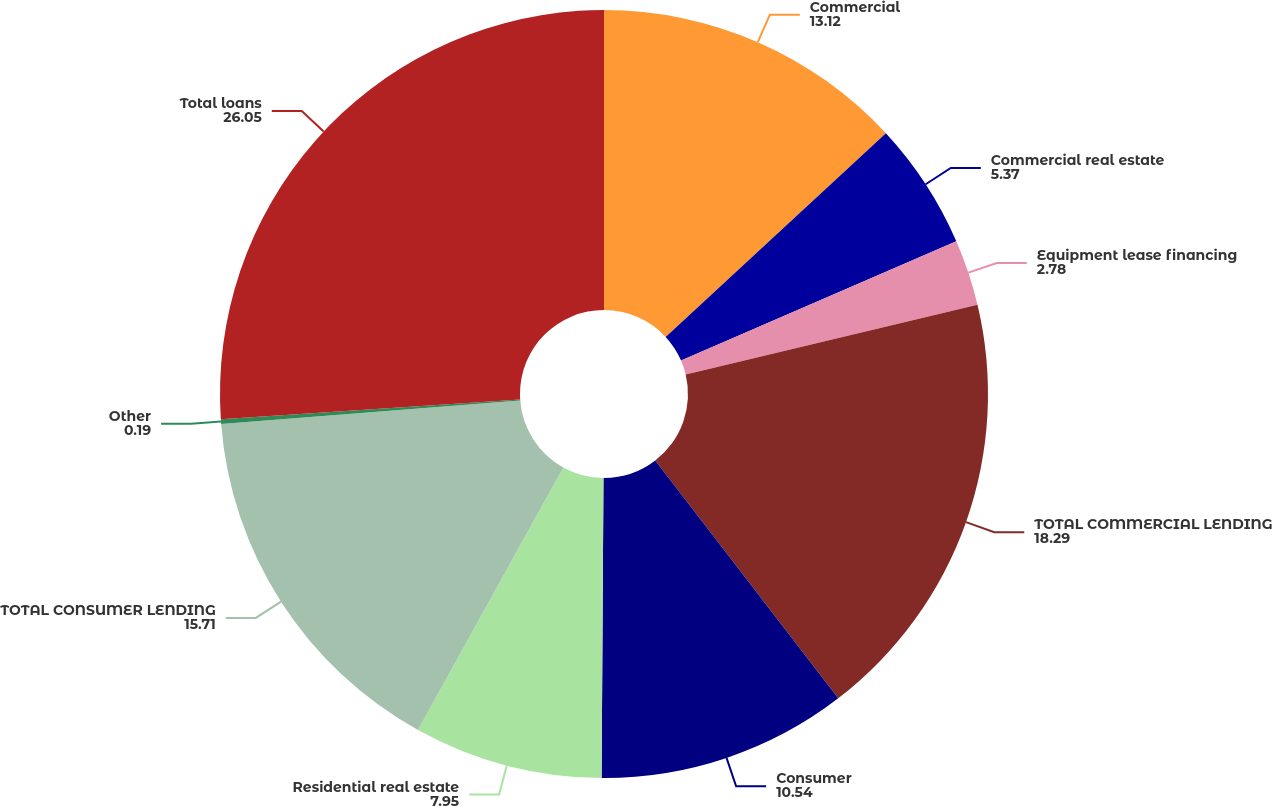Convert chart to OTSL. <chart><loc_0><loc_0><loc_500><loc_500><pie_chart><fcel>Commercial<fcel>Commercial real estate<fcel>Equipment lease financing<fcel>TOTAL COMMERCIAL LENDING<fcel>Consumer<fcel>Residential real estate<fcel>TOTAL CONSUMER LENDING<fcel>Other<fcel>Total loans<nl><fcel>13.12%<fcel>5.37%<fcel>2.78%<fcel>18.29%<fcel>10.54%<fcel>7.95%<fcel>15.71%<fcel>0.19%<fcel>26.05%<nl></chart> 